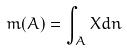Convert formula to latex. <formula><loc_0><loc_0><loc_500><loc_500>m ( A ) = \int _ { A } X d n</formula> 